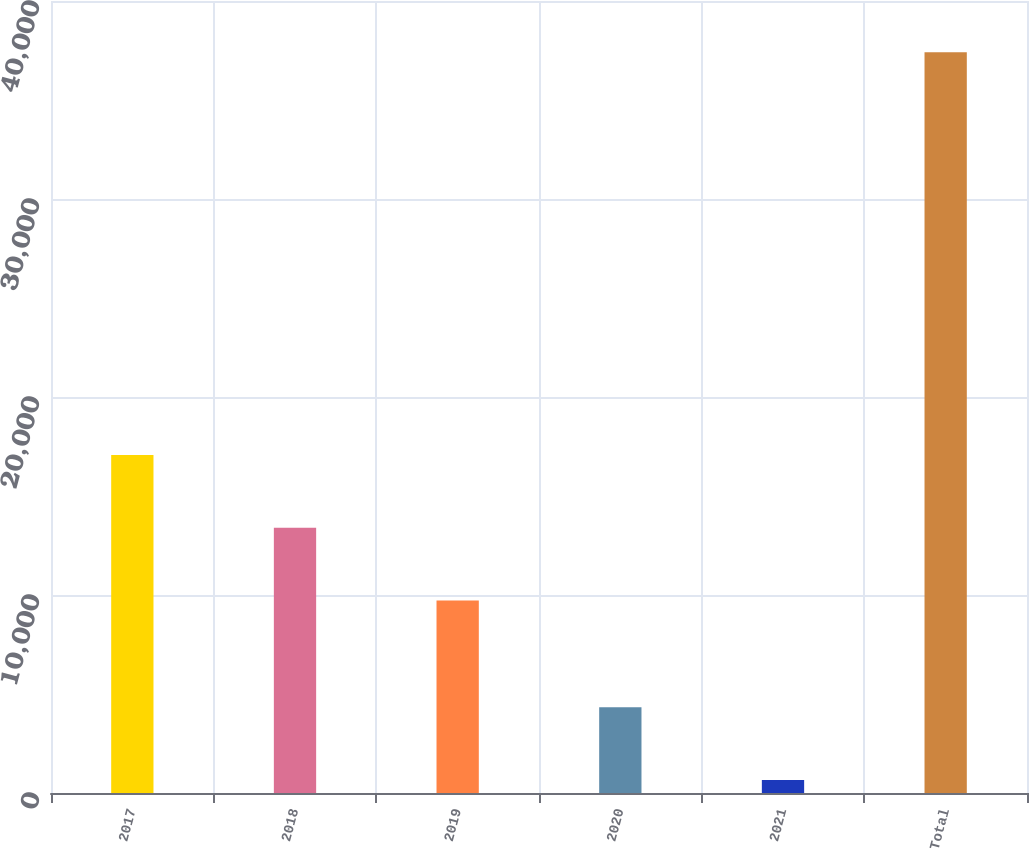Convert chart to OTSL. <chart><loc_0><loc_0><loc_500><loc_500><bar_chart><fcel>2017<fcel>2018<fcel>2019<fcel>2020<fcel>2021<fcel>Total<nl><fcel>17076.6<fcel>13400.3<fcel>9724<fcel>4328.3<fcel>652<fcel>37415<nl></chart> 